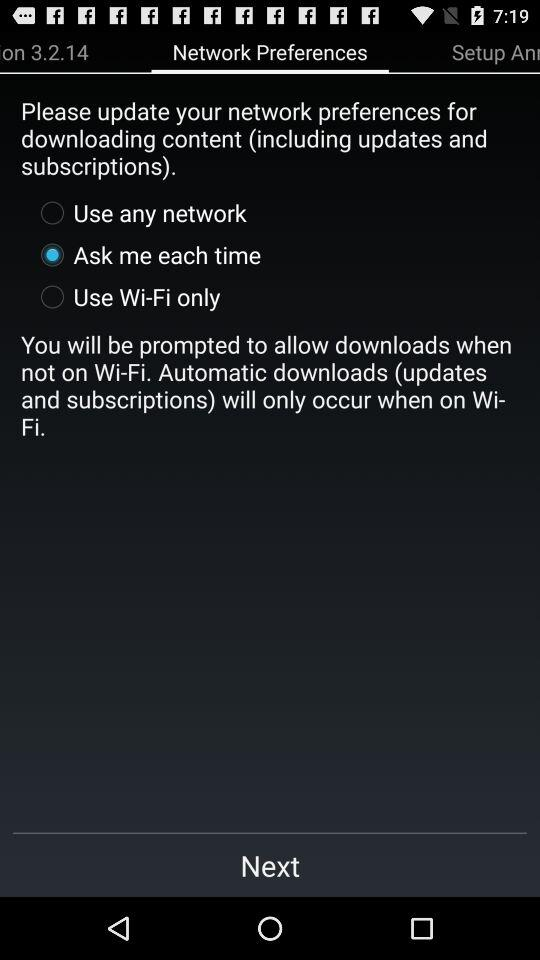What is written in "Setup An..."?
When the provided information is insufficient, respond with <no answer>. <no answer> 